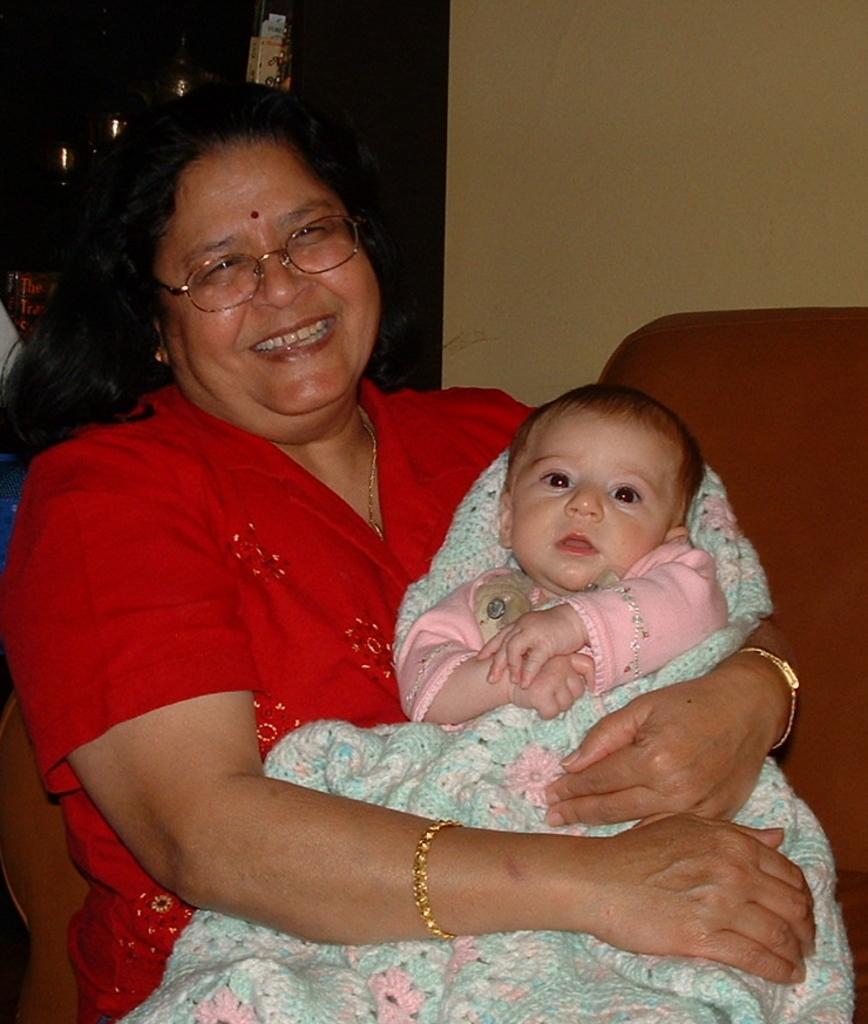Please provide a concise description of this image. In this image, we can see a few people. We can see the wall. We can see a chair. In the background, we can see some objects. 